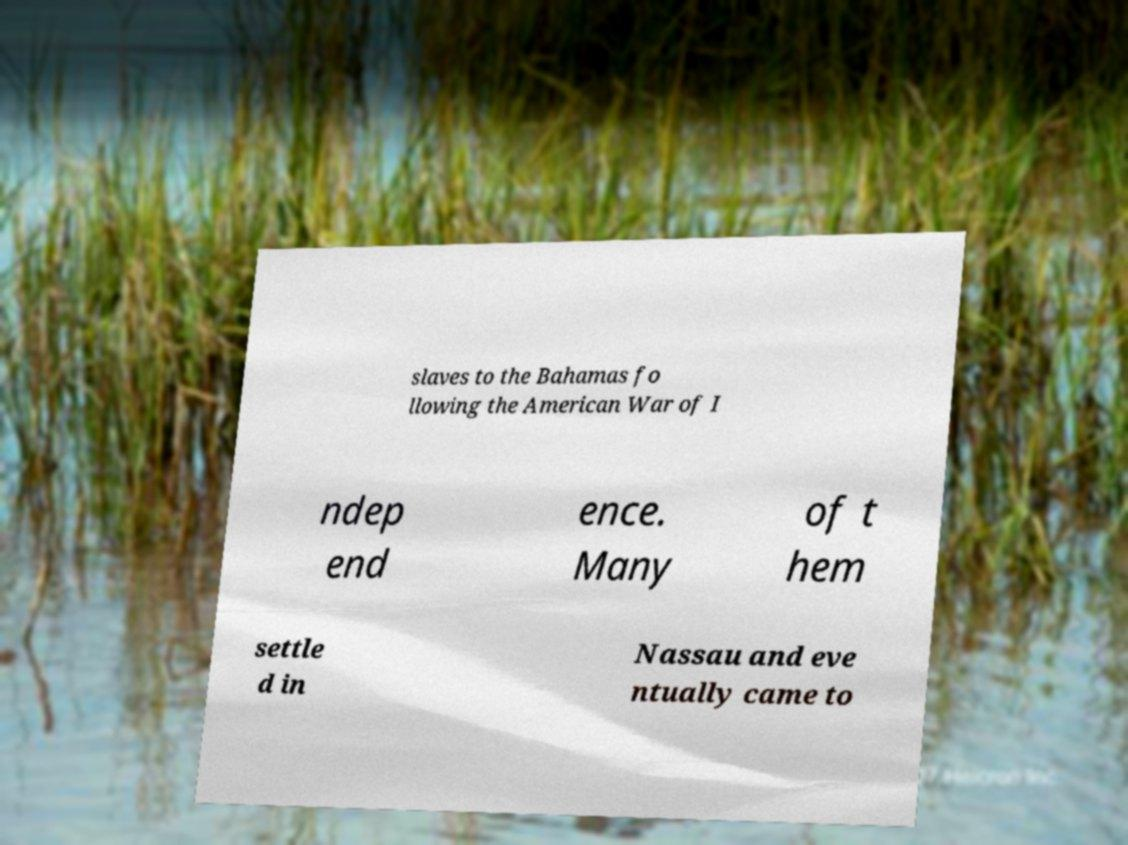Please identify and transcribe the text found in this image. slaves to the Bahamas fo llowing the American War of I ndep end ence. Many of t hem settle d in Nassau and eve ntually came to 